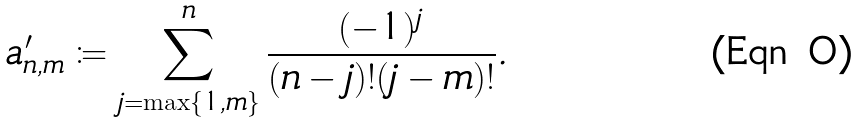<formula> <loc_0><loc_0><loc_500><loc_500>a ^ { \prime } _ { n , m } \coloneqq \sum _ { j = \max \{ 1 , m \} } ^ { n } \frac { ( - 1 ) ^ { j } } { ( n - j ) ! ( j - m ) ! } .</formula> 